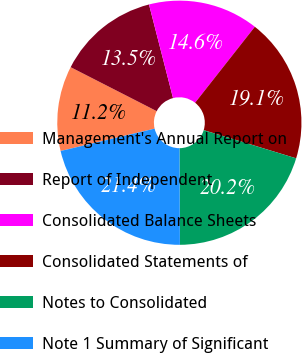Convert chart. <chart><loc_0><loc_0><loc_500><loc_500><pie_chart><fcel>Management's Annual Report on<fcel>Report of Independent<fcel>Consolidated Balance Sheets<fcel>Consolidated Statements of<fcel>Notes to Consolidated<fcel>Note 1 Summary of Significant<nl><fcel>11.24%<fcel>13.48%<fcel>14.61%<fcel>19.1%<fcel>20.22%<fcel>21.35%<nl></chart> 